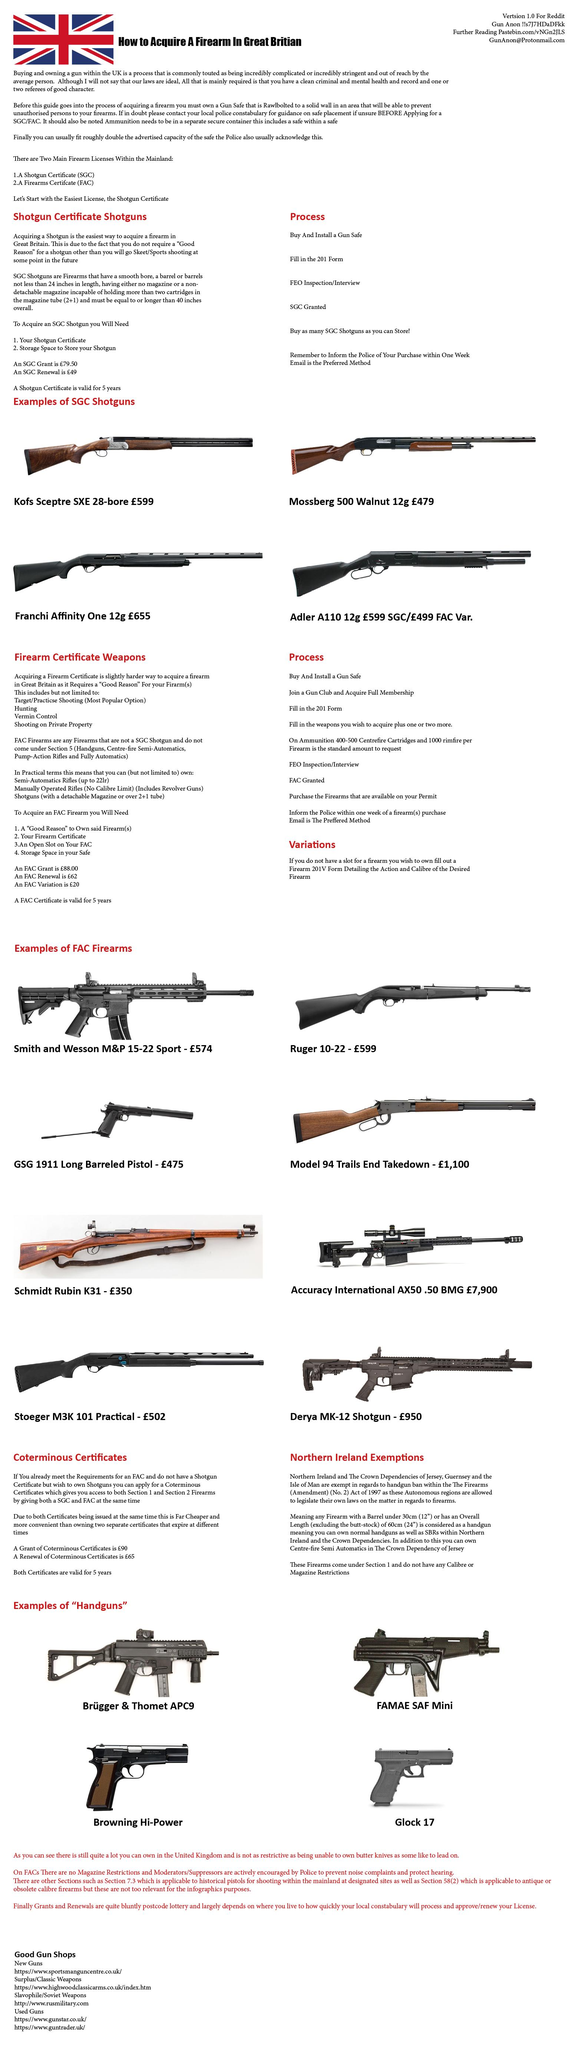Identify some key points in this picture. In the UK, there are two major types of firearm licenses: a shotgun certificate (SGC) and a Firearms Certificate (FAC). The Shortgun certificate expires after five years from the date of issue. 